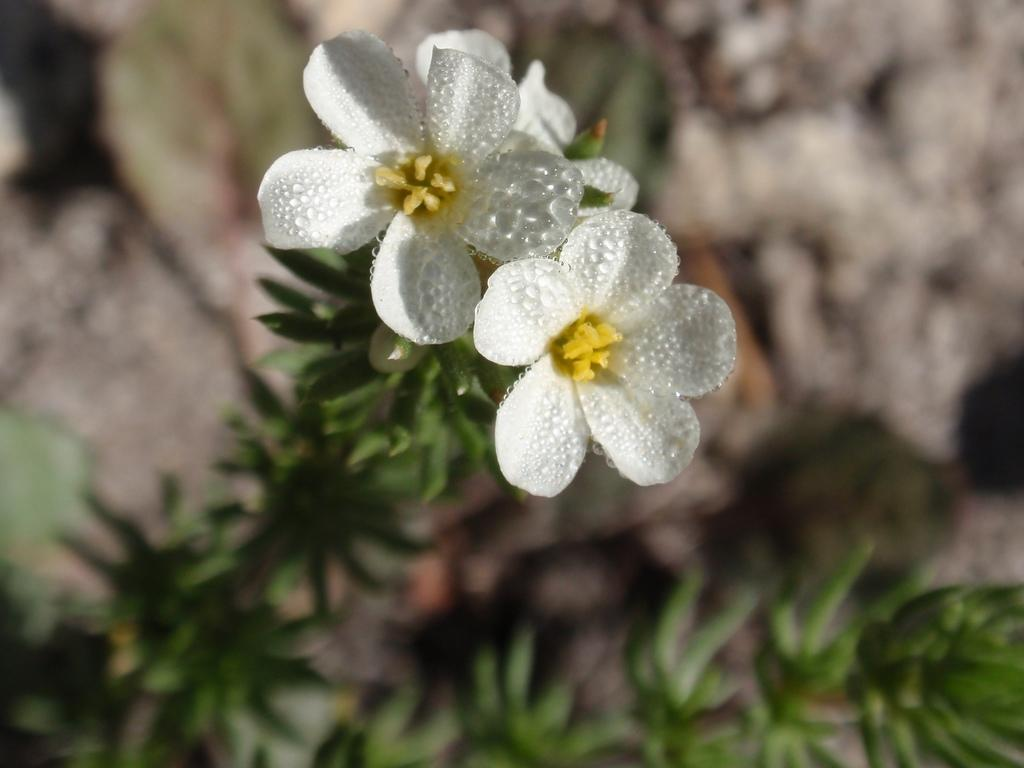What type of plant is visible in the image? There is a plant with flowers in the image. Can you describe the background of the image? The background of the image is blurred. Are there any dinosaurs visible in the image? No, there are no dinosaurs present in the image. What type of material is the plant's vase made of? There is no vase present in the image, as the plant appears to be in a natural setting. 